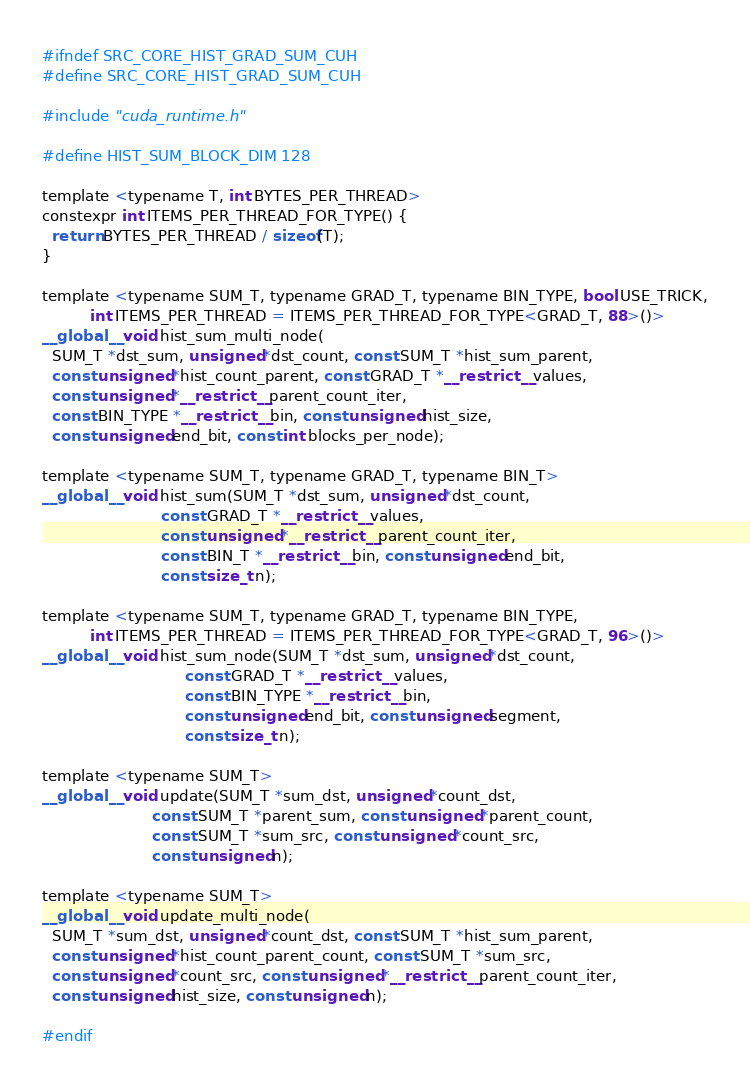<code> <loc_0><loc_0><loc_500><loc_500><_Cuda_>#ifndef SRC_CORE_HIST_GRAD_SUM_CUH
#define SRC_CORE_HIST_GRAD_SUM_CUH

#include "cuda_runtime.h"

#define HIST_SUM_BLOCK_DIM 128

template <typename T, int BYTES_PER_THREAD>
constexpr int ITEMS_PER_THREAD_FOR_TYPE() {
  return BYTES_PER_THREAD / sizeof(T);
}

template <typename SUM_T, typename GRAD_T, typename BIN_TYPE, bool USE_TRICK,
          int ITEMS_PER_THREAD = ITEMS_PER_THREAD_FOR_TYPE<GRAD_T, 88>()>
__global__ void hist_sum_multi_node(
  SUM_T *dst_sum, unsigned *dst_count, const SUM_T *hist_sum_parent,
  const unsigned *hist_count_parent, const GRAD_T *__restrict__ values,
  const unsigned *__restrict__ parent_count_iter,
  const BIN_TYPE *__restrict__ bin, const unsigned hist_size,
  const unsigned end_bit, const int blocks_per_node);

template <typename SUM_T, typename GRAD_T, typename BIN_T>
__global__ void hist_sum(SUM_T *dst_sum, unsigned *dst_count,
                         const GRAD_T *__restrict__ values,
                         const unsigned *__restrict__ parent_count_iter,
                         const BIN_T *__restrict__ bin, const unsigned end_bit,
                         const size_t n);

template <typename SUM_T, typename GRAD_T, typename BIN_TYPE,
          int ITEMS_PER_THREAD = ITEMS_PER_THREAD_FOR_TYPE<GRAD_T, 96>()>
__global__ void hist_sum_node(SUM_T *dst_sum, unsigned *dst_count,
                              const GRAD_T *__restrict__ values,
                              const BIN_TYPE *__restrict__ bin,
                              const unsigned end_bit, const unsigned segment,
                              const size_t n);

template <typename SUM_T>
__global__ void update(SUM_T *sum_dst, unsigned *count_dst,
                       const SUM_T *parent_sum, const unsigned *parent_count,
                       const SUM_T *sum_src, const unsigned *count_src,
                       const unsigned n);

template <typename SUM_T>
__global__ void update_multi_node(
  SUM_T *sum_dst, unsigned *count_dst, const SUM_T *hist_sum_parent,
  const unsigned *hist_count_parent_count, const SUM_T *sum_src,
  const unsigned *count_src, const unsigned *__restrict__ parent_count_iter,
  const unsigned hist_size, const unsigned n);

#endif</code> 